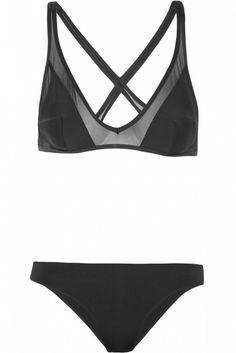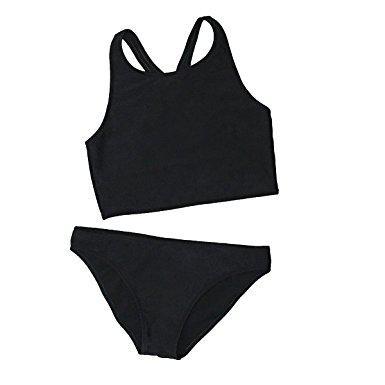The first image is the image on the left, the second image is the image on the right. For the images shown, is this caption "One bikini has a tieable strap." true? Answer yes or no. No. 